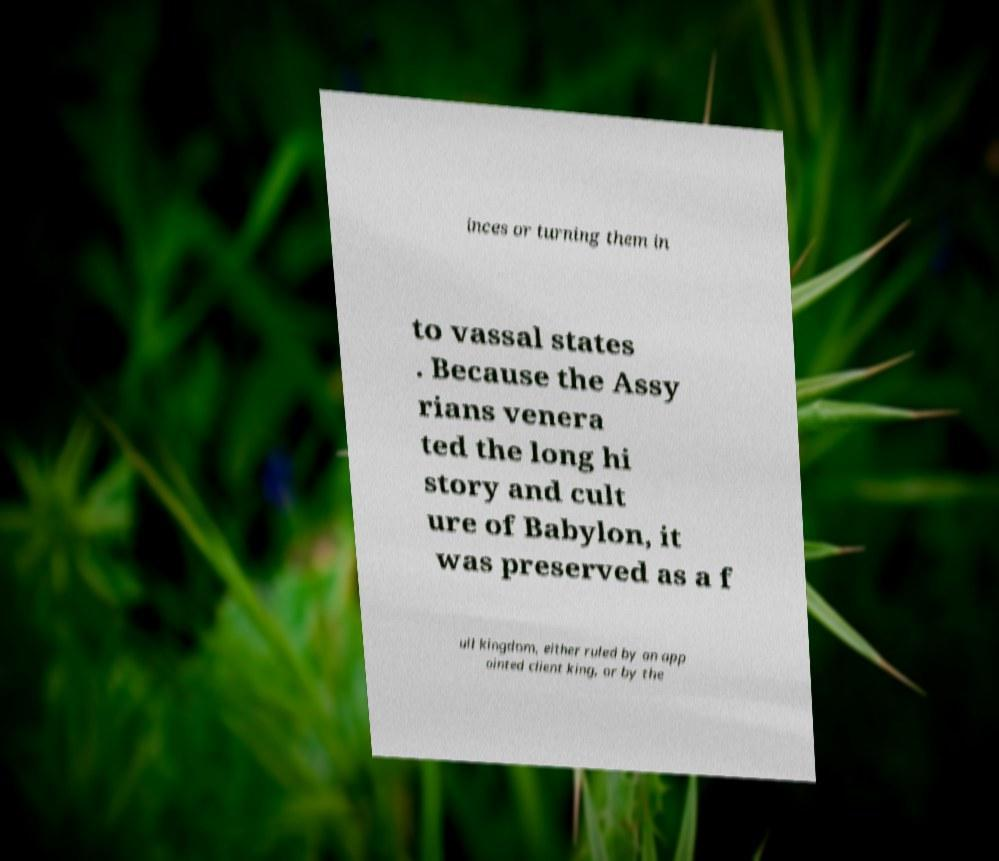Could you assist in decoding the text presented in this image and type it out clearly? inces or turning them in to vassal states . Because the Assy rians venera ted the long hi story and cult ure of Babylon, it was preserved as a f ull kingdom, either ruled by an app ointed client king, or by the 